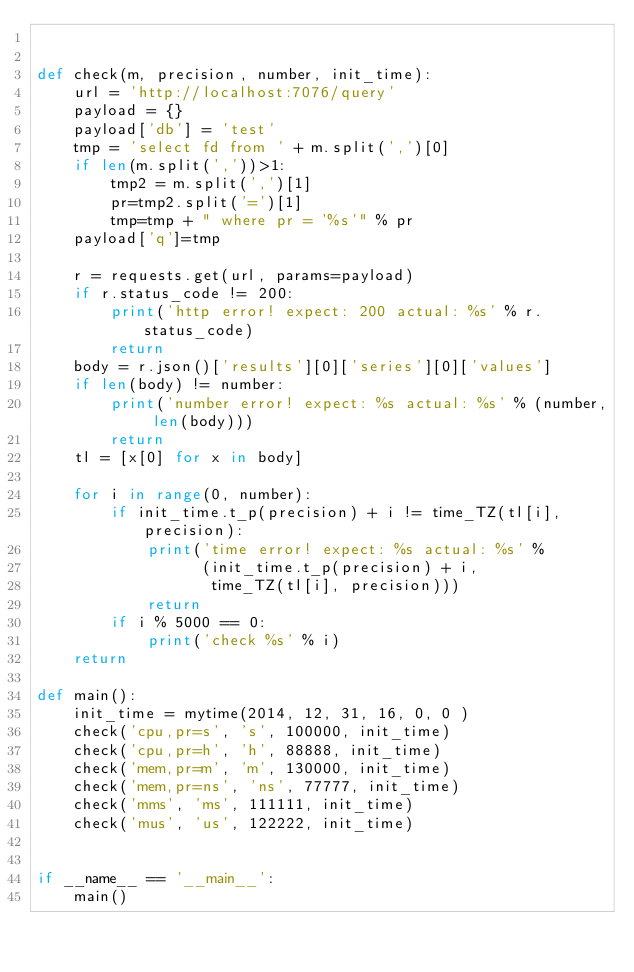<code> <loc_0><loc_0><loc_500><loc_500><_Python_>

def check(m, precision, number, init_time):
    url = 'http://localhost:7076/query'
    payload = {}
    payload['db'] = 'test'
    tmp = 'select fd from ' + m.split(',')[0]
    if len(m.split(','))>1:
        tmp2 = m.split(',')[1]
        pr=tmp2.split('=')[1]
        tmp=tmp + " where pr = '%s'" % pr
    payload['q']=tmp

    r = requests.get(url, params=payload)
    if r.status_code != 200:
        print('http error! expect: 200 actual: %s' % r.status_code)
        return
    body = r.json()['results'][0]['series'][0]['values']
    if len(body) != number:
        print('number error! expect: %s actual: %s' % (number, len(body)))
        return
    tl = [x[0] for x in body]

    for i in range(0, number):
        if init_time.t_p(precision) + i != time_TZ(tl[i], precision):
            print('time error! expect: %s actual: %s' %
                  (init_time.t_p(precision) + i,
                   time_TZ(tl[i], precision)))
            return
        if i % 5000 == 0:
            print('check %s' % i)
    return

def main():
    init_time = mytime(2014, 12, 31, 16, 0, 0 )
    check('cpu,pr=s', 's', 100000, init_time)
    check('cpu,pr=h', 'h', 88888, init_time)
    check('mem,pr=m', 'm', 130000, init_time)
    check('mem,pr=ns', 'ns', 77777, init_time)
    check('mms', 'ms', 111111, init_time)
    check('mus', 'us', 122222, init_time)


if __name__ == '__main__':
    main()</code> 